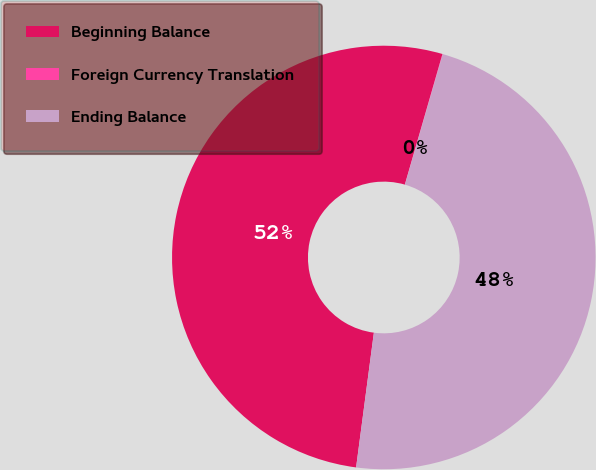<chart> <loc_0><loc_0><loc_500><loc_500><pie_chart><fcel>Beginning Balance<fcel>Foreign Currency Translation<fcel>Ending Balance<nl><fcel>52.38%<fcel>0.03%<fcel>47.59%<nl></chart> 